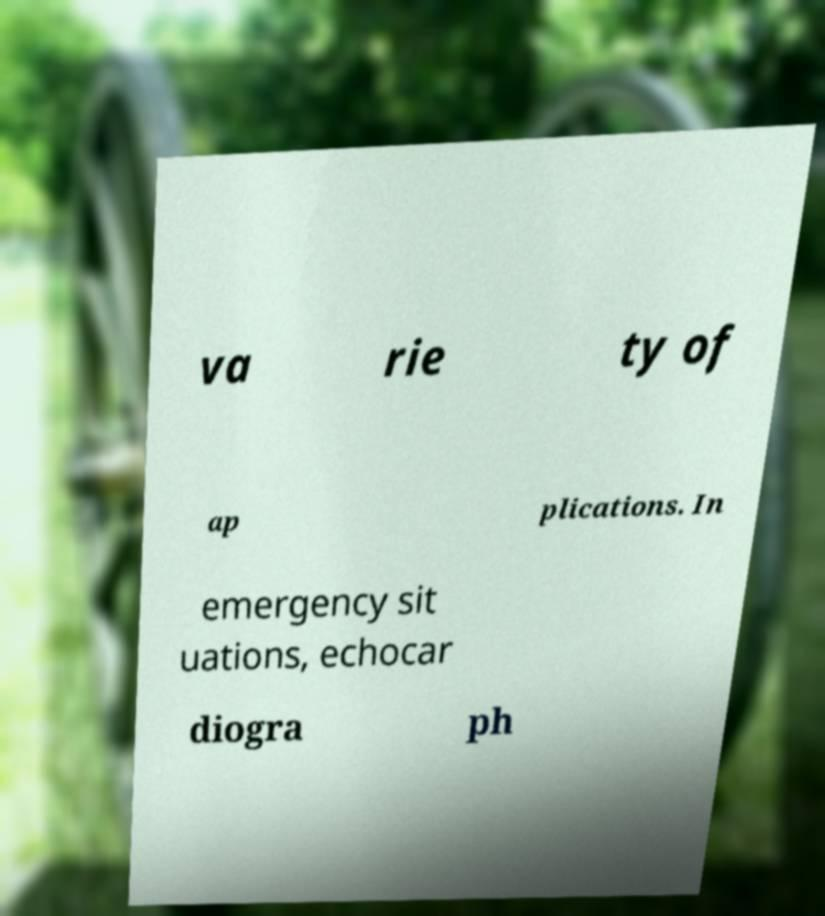Please read and relay the text visible in this image. What does it say? va rie ty of ap plications. In emergency sit uations, echocar diogra ph 